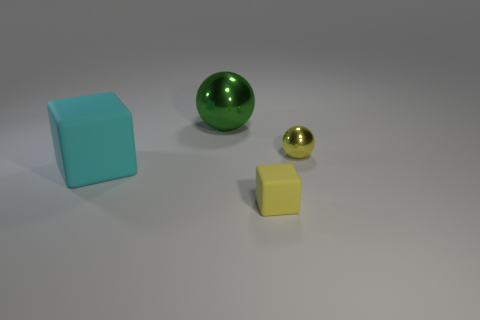There is a rubber block that is on the left side of the matte block that is to the right of the big metallic sphere; how big is it?
Offer a terse response. Large. Are there any other metal things of the same size as the green metallic object?
Offer a terse response. No. What is the color of the other object that is the same material as the green thing?
Give a very brief answer. Yellow. Are there fewer small objects than cyan matte blocks?
Make the answer very short. No. What is the material of the object that is on the right side of the large cyan rubber thing and in front of the small yellow ball?
Provide a short and direct response. Rubber. Is there a small thing that is in front of the ball that is in front of the large ball?
Offer a terse response. Yes. How many tiny metal balls are the same color as the tiny matte cube?
Give a very brief answer. 1. What material is the small object that is the same color as the tiny cube?
Make the answer very short. Metal. Do the green object and the small sphere have the same material?
Provide a short and direct response. Yes. Are there any large cyan rubber cubes behind the tiny yellow sphere?
Keep it short and to the point. No. 